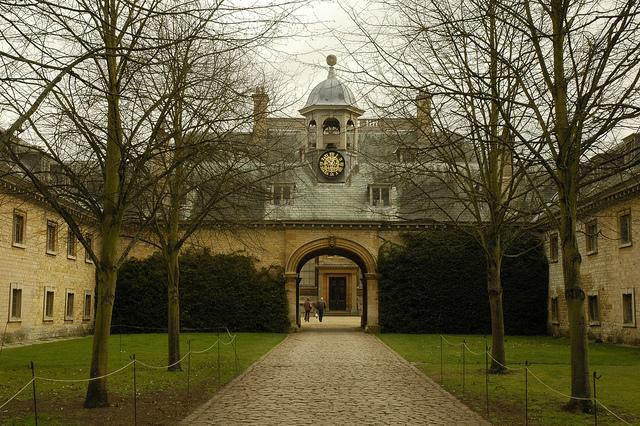What does this setting most resemble?

Choices:
A) college campus
B) tundra
C) circus
D) desert college campus 